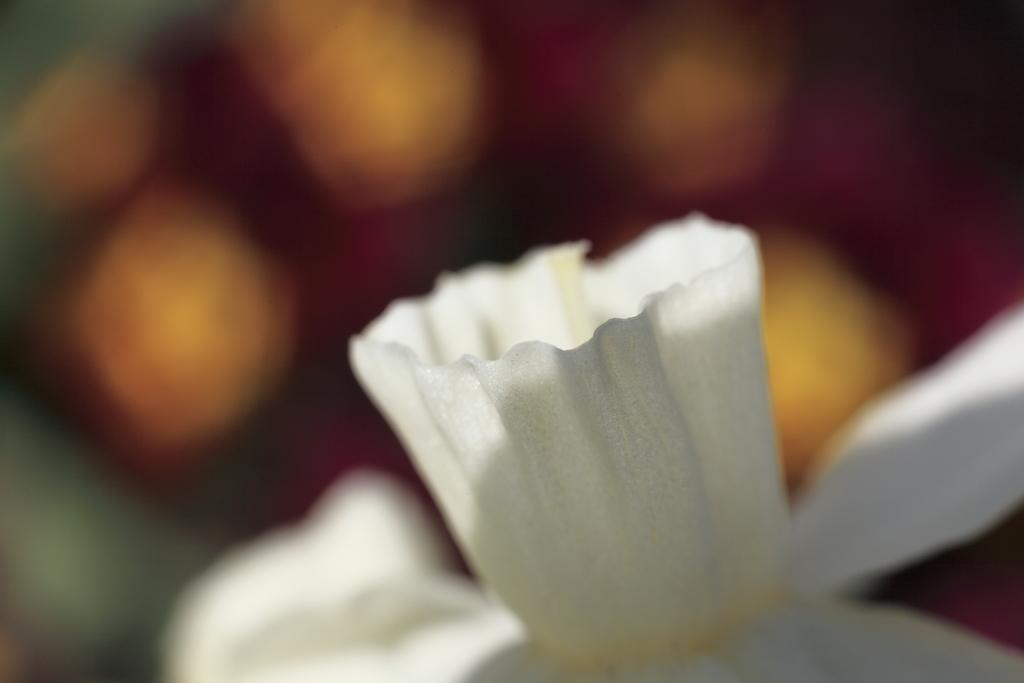What is the main subject in the foreground of the image? There is a white color object in the foreground of the image, which appears to be a flower. Can you describe the background of the image? The background of the image is blurry. Can you see any cables connecting the flower to a power source in the image? There are no cables or power sources visible in the image; it features a flower in the foreground and a blurry background. Is there a pig present in the image? There is no pig present in the image. 